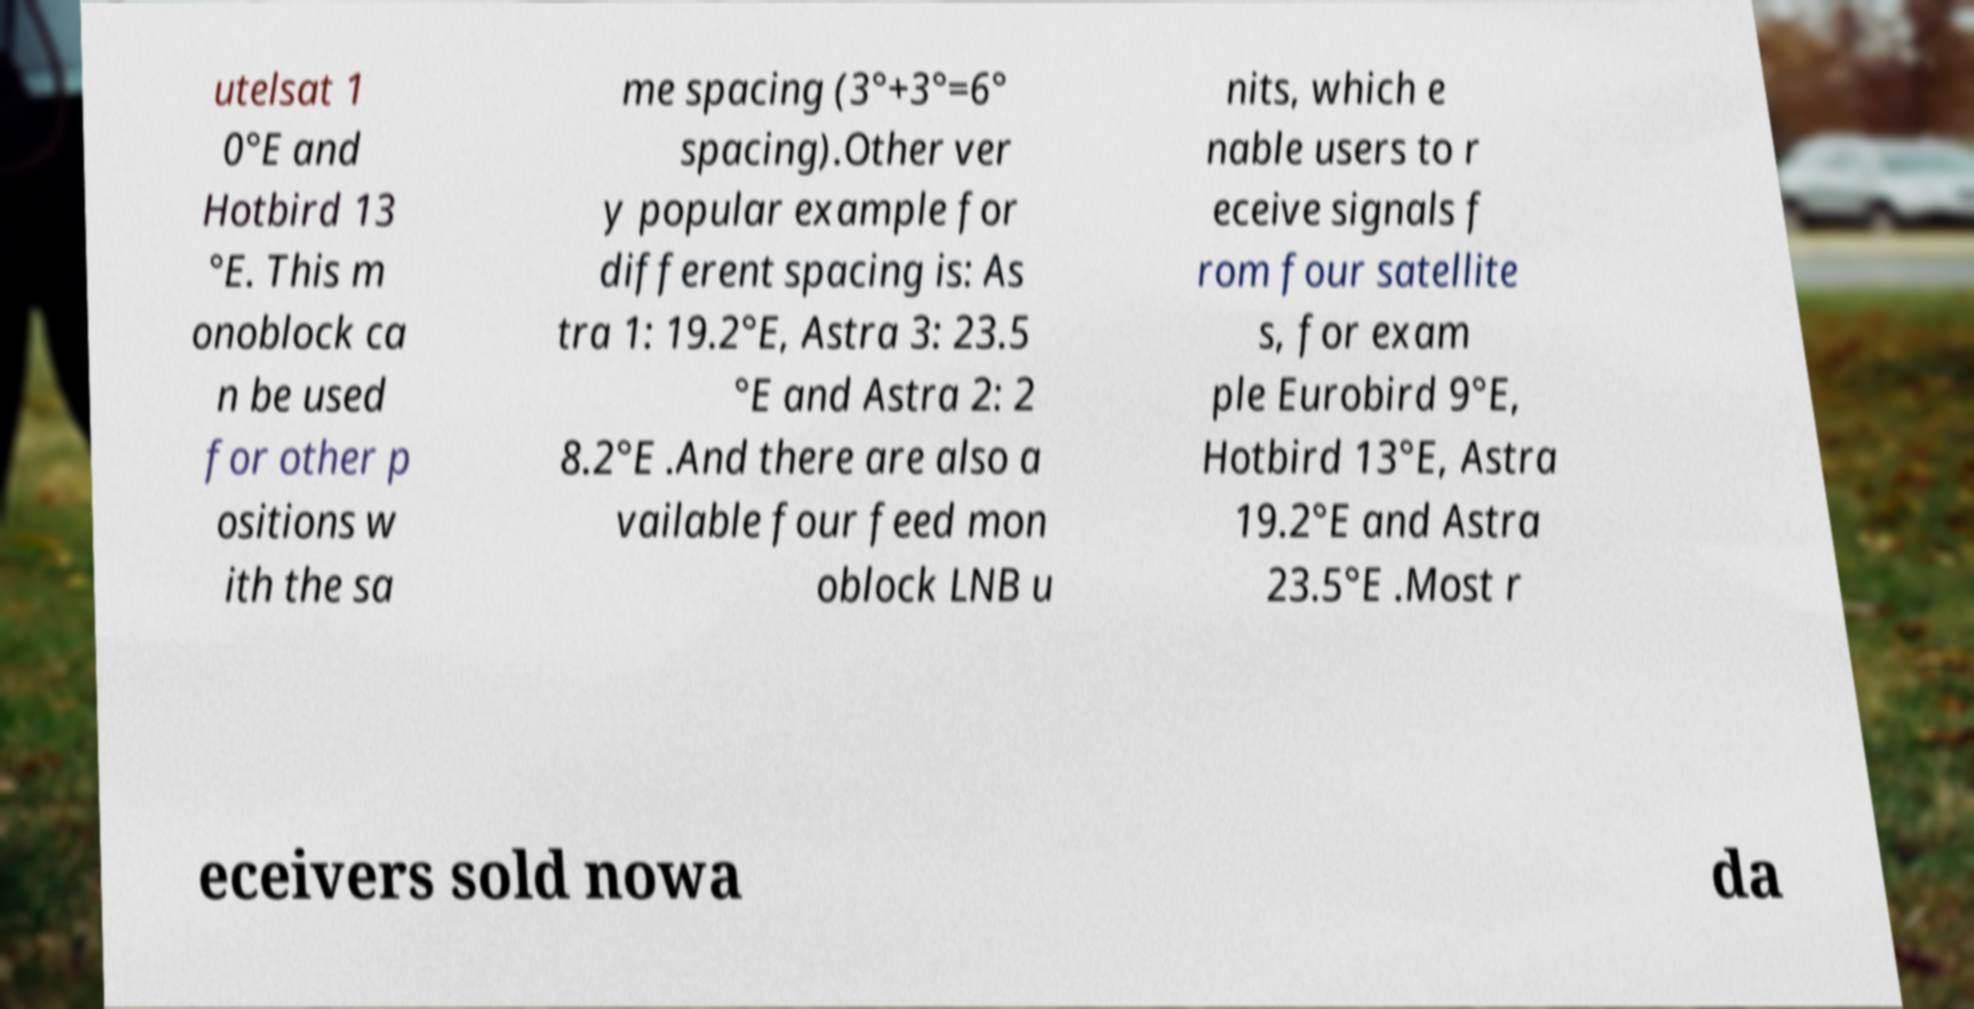What messages or text are displayed in this image? I need them in a readable, typed format. utelsat 1 0°E and Hotbird 13 °E. This m onoblock ca n be used for other p ositions w ith the sa me spacing (3°+3°=6° spacing).Other ver y popular example for different spacing is: As tra 1: 19.2°E, Astra 3: 23.5 °E and Astra 2: 2 8.2°E .And there are also a vailable four feed mon oblock LNB u nits, which e nable users to r eceive signals f rom four satellite s, for exam ple Eurobird 9°E, Hotbird 13°E, Astra 19.2°E and Astra 23.5°E .Most r eceivers sold nowa da 